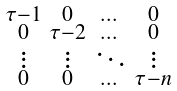<formula> <loc_0><loc_0><loc_500><loc_500>\begin{smallmatrix} \tau - 1 & 0 & \dots & 0 \\ 0 & \tau - 2 & \dots & 0 \\ \vdots & \vdots & \ddots & \vdots \\ 0 & 0 & \dots & \tau - n \end{smallmatrix}</formula> 